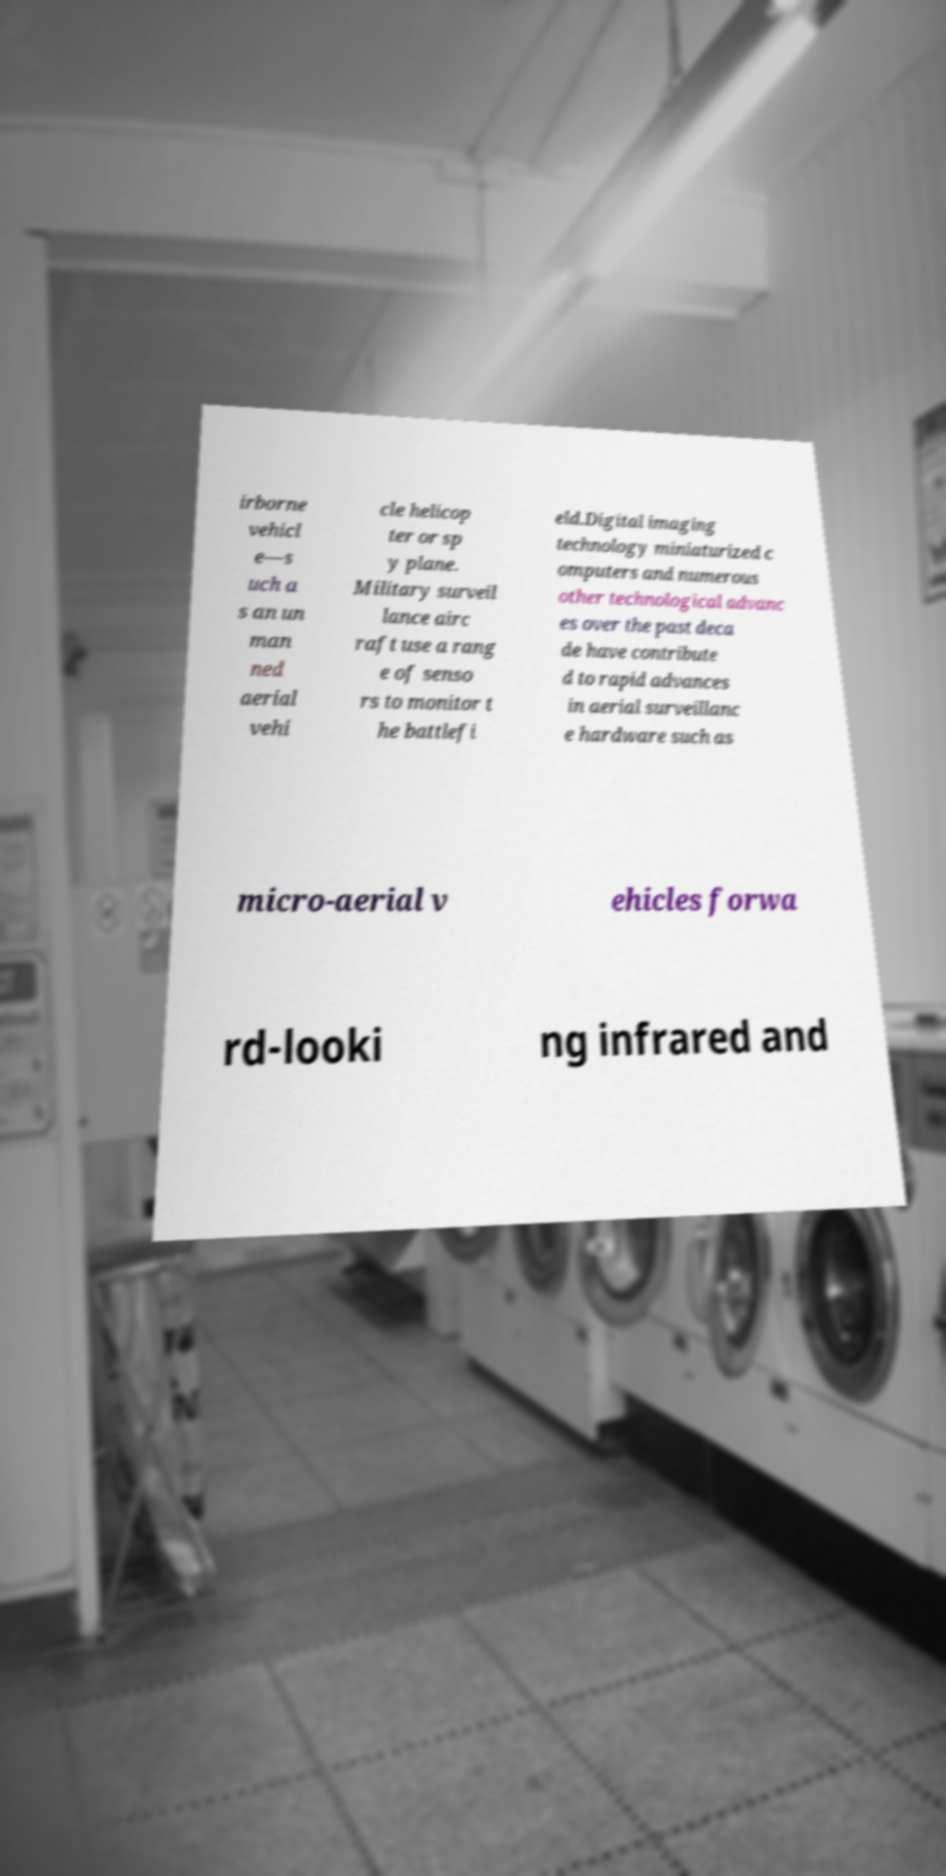Could you extract and type out the text from this image? irborne vehicl e—s uch a s an un man ned aerial vehi cle helicop ter or sp y plane. Military surveil lance airc raft use a rang e of senso rs to monitor t he battlefi eld.Digital imaging technology miniaturized c omputers and numerous other technological advanc es over the past deca de have contribute d to rapid advances in aerial surveillanc e hardware such as micro-aerial v ehicles forwa rd-looki ng infrared and 